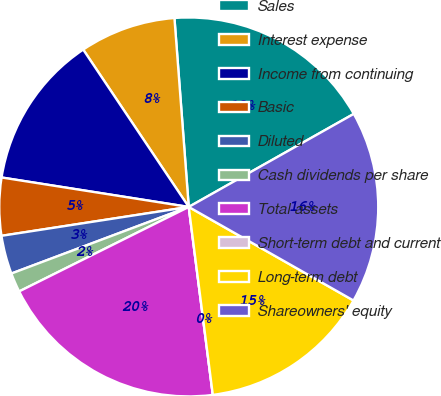<chart> <loc_0><loc_0><loc_500><loc_500><pie_chart><fcel>Sales<fcel>Interest expense<fcel>Income from continuing<fcel>Basic<fcel>Diluted<fcel>Cash dividends per share<fcel>Total assets<fcel>Short-term debt and current<fcel>Long-term debt<fcel>Shareowners' equity<nl><fcel>18.03%<fcel>8.2%<fcel>13.11%<fcel>4.92%<fcel>3.28%<fcel>1.64%<fcel>19.67%<fcel>0.0%<fcel>14.75%<fcel>16.39%<nl></chart> 